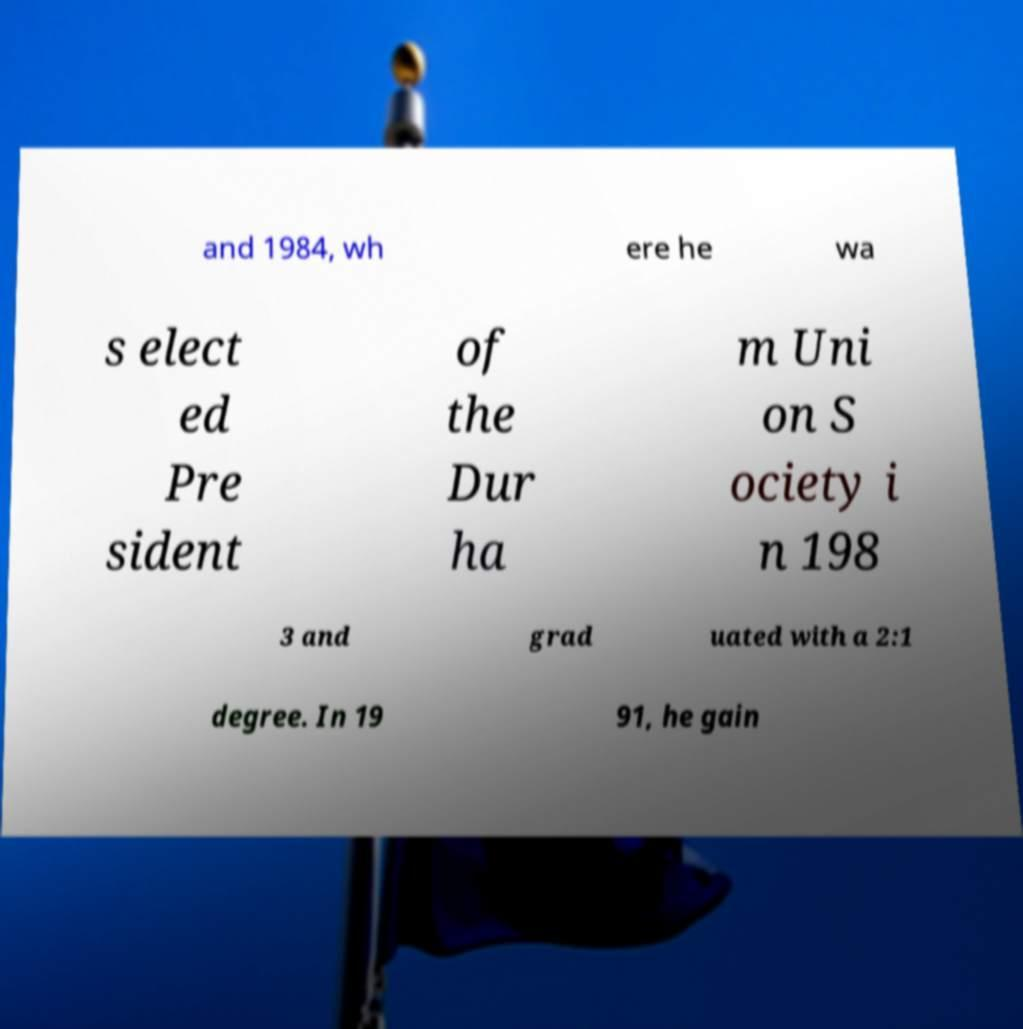Could you extract and type out the text from this image? and 1984, wh ere he wa s elect ed Pre sident of the Dur ha m Uni on S ociety i n 198 3 and grad uated with a 2:1 degree. In 19 91, he gain 